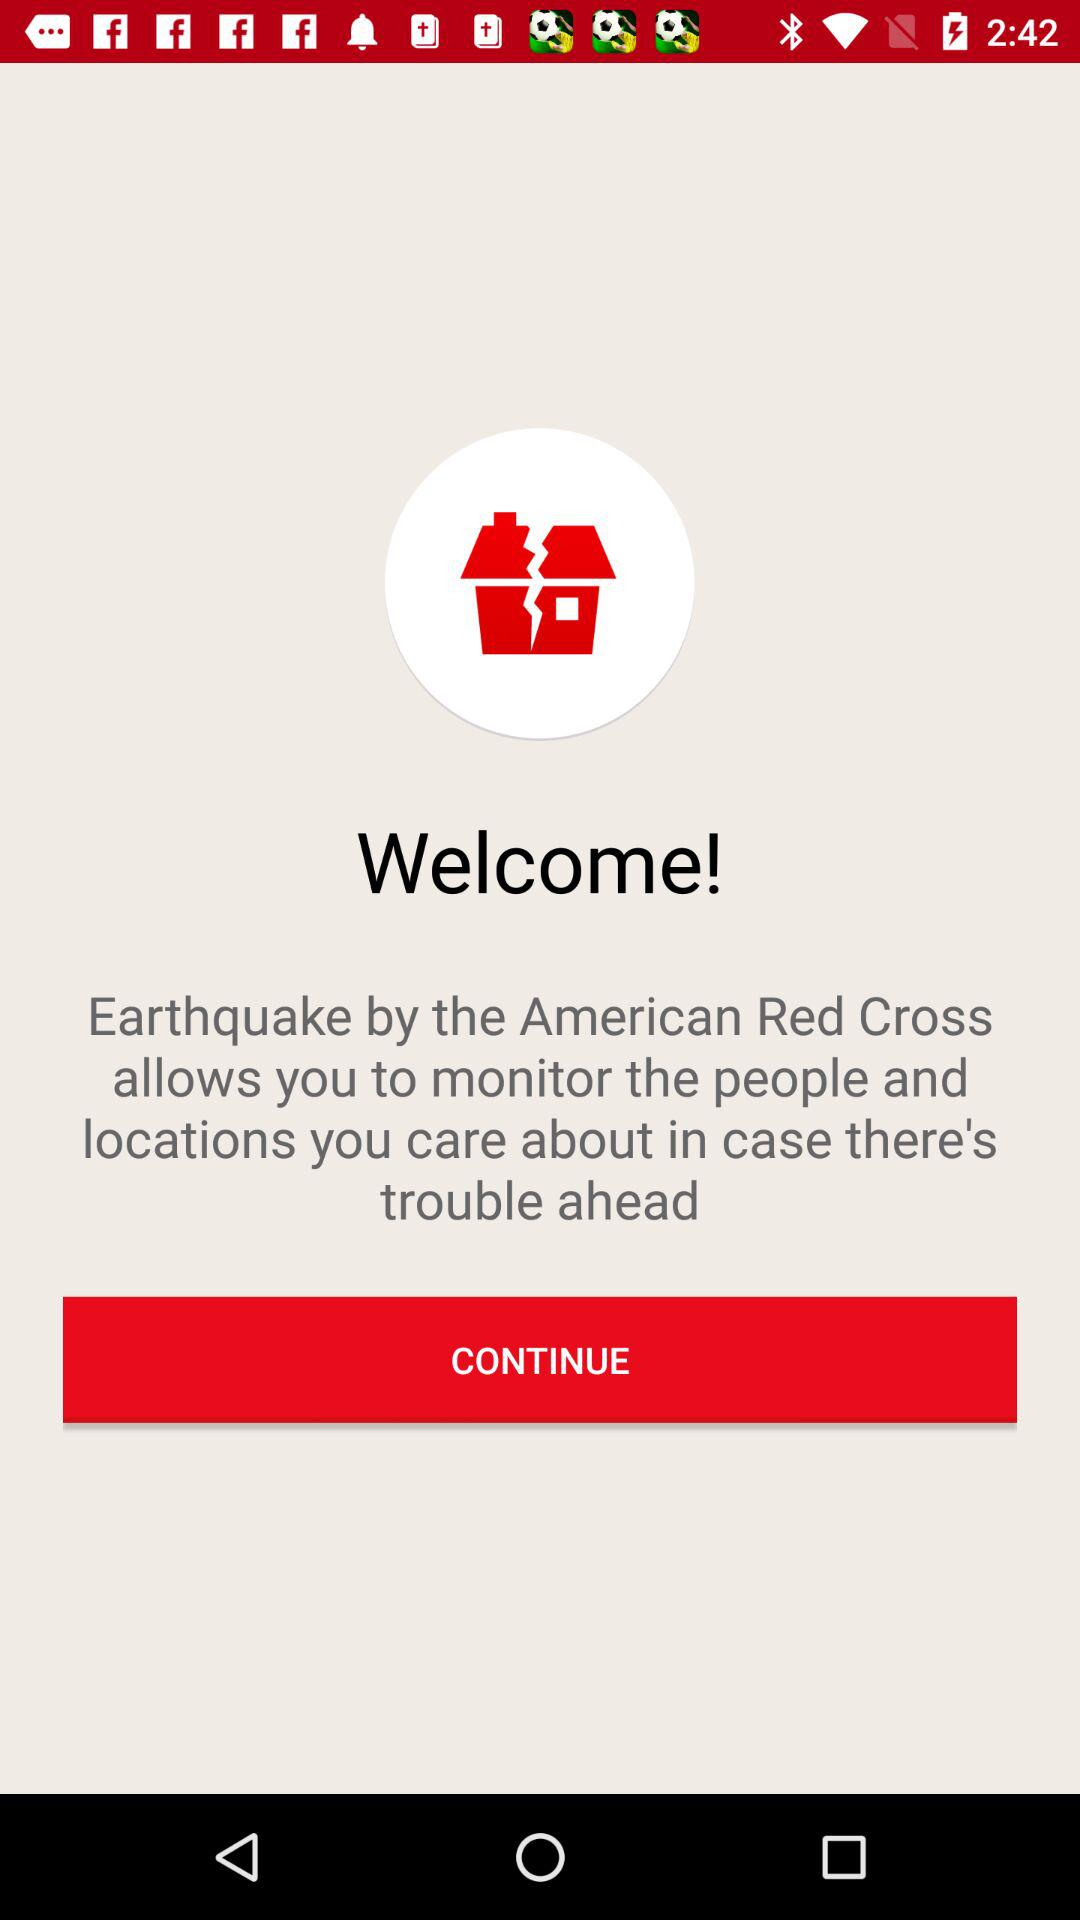What is the app name? The app name is "Earthquake". 